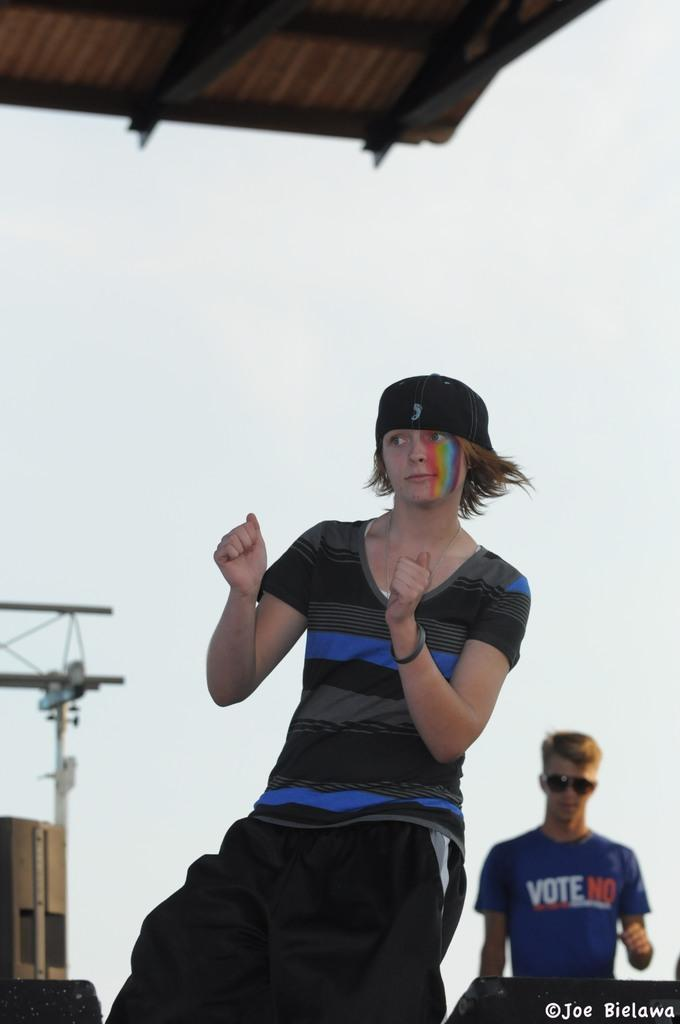<image>
Provide a brief description of the given image. A person in the background wearing a shirt that says Vote No. 